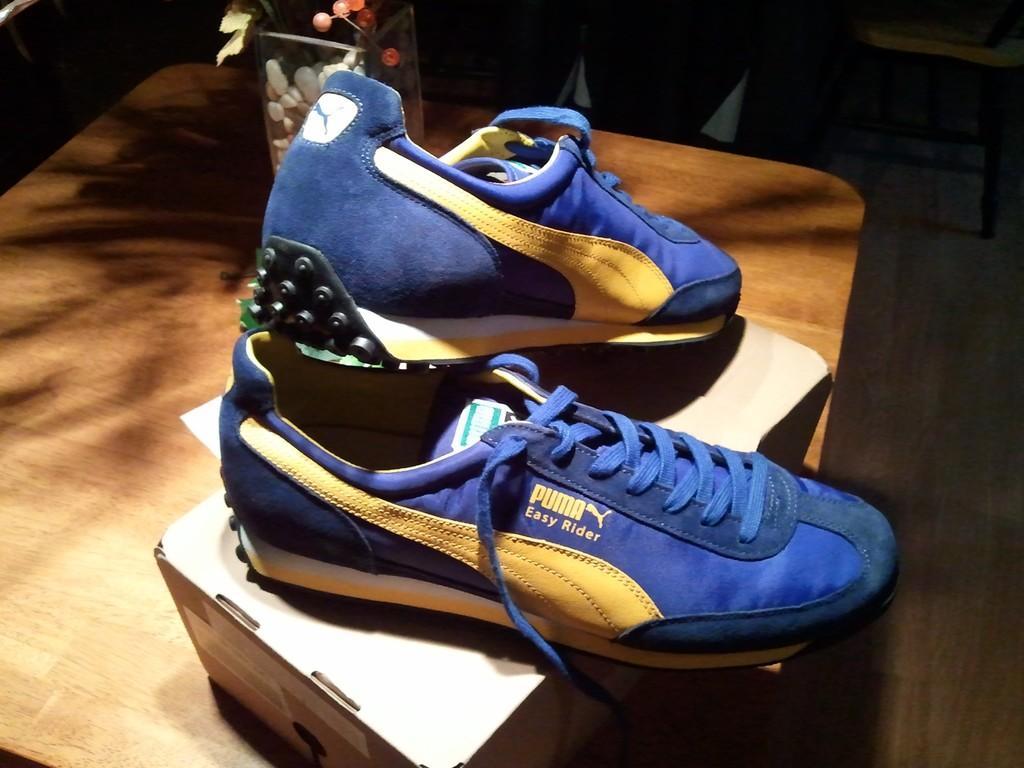Describe this image in one or two sentences. This picture shows a pair of shoes on the table and we see a box and the shoes are blue and yellow in color and we see a glass box with a plant on the table. 